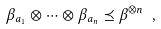Convert formula to latex. <formula><loc_0><loc_0><loc_500><loc_500>\beta _ { a _ { 1 } } \otimes \cdots \otimes \beta _ { a _ { n } } \preceq \beta ^ { \otimes n } \ ,</formula> 